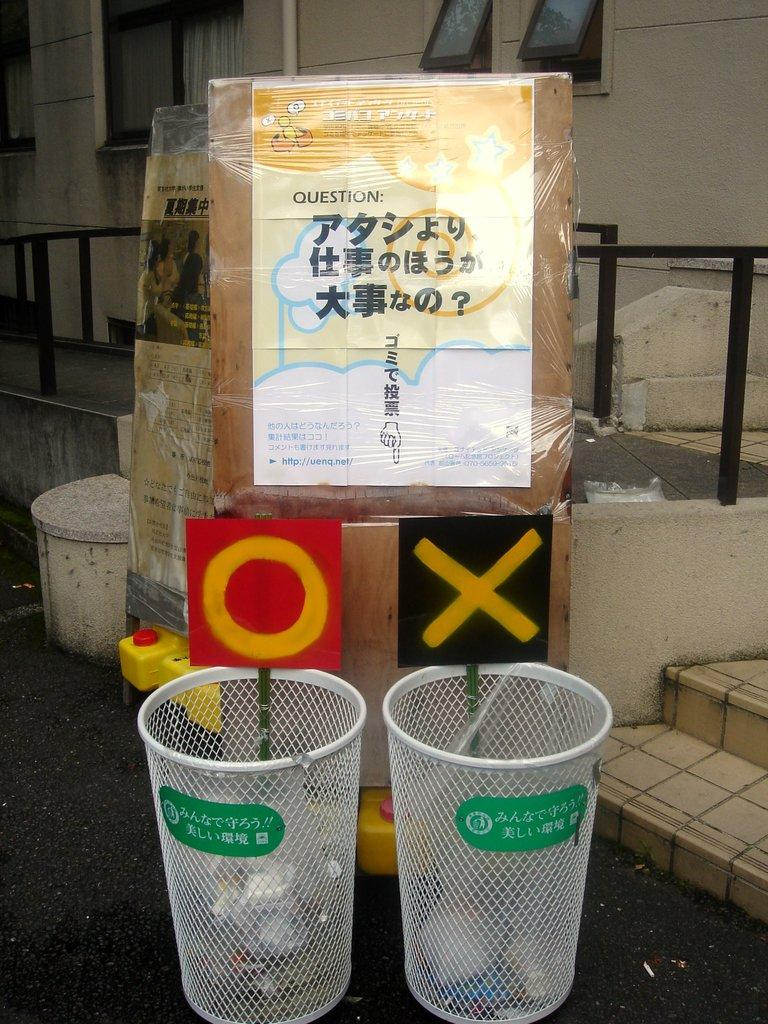<image>
Summarize the visual content of the image. One trash can has an O over it, and the other has an X over it. 